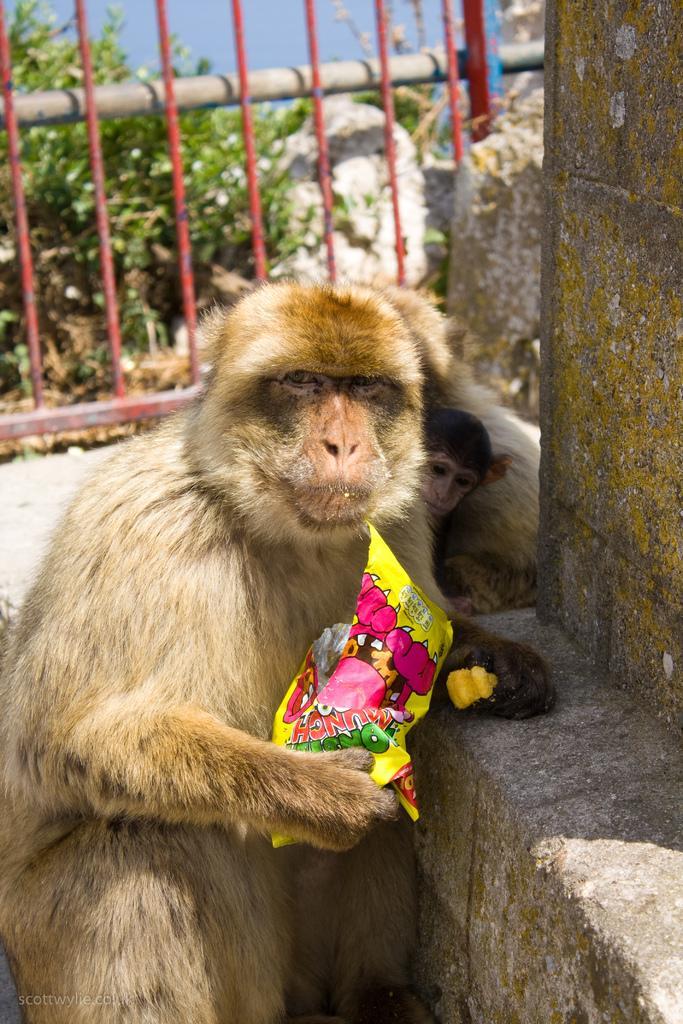Could you give a brief overview of what you see in this image? In the image I can see a monkey which is holding some packet and behind there is a fencing and also I can see some plants to the other side of the fencing. 